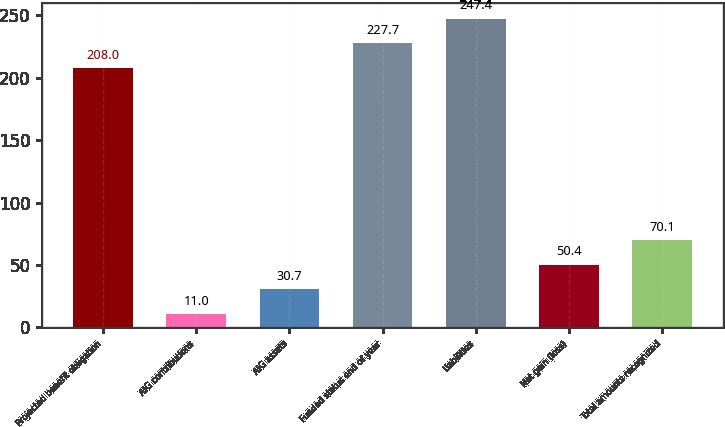Convert chart to OTSL. <chart><loc_0><loc_0><loc_500><loc_500><bar_chart><fcel>Projected benefit obligation<fcel>AIG contributions<fcel>AIG assets<fcel>Funded status end of year<fcel>Liabilities<fcel>Net gain (loss)<fcel>Total amounts recognized<nl><fcel>208<fcel>11<fcel>30.7<fcel>227.7<fcel>247.4<fcel>50.4<fcel>70.1<nl></chart> 